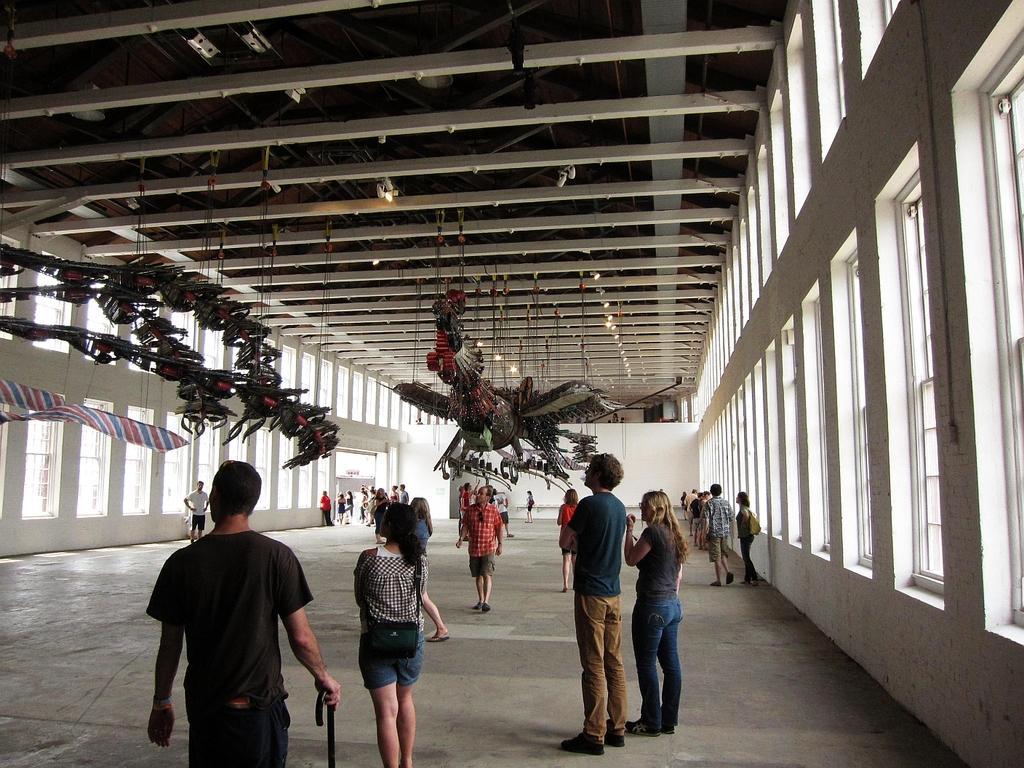In one or two sentences, can you explain what this image depicts? This picture shows the inner view of a building. There are three objects hanged to the ceiling, dome lights attached to the ceiling, some rods attached to the ceiling, some people are standing, some people are walking, some objects attached to the ceiling, some people are holding some objects, two persons wearing badges, some objects attached to the wall and one object on the ground. 